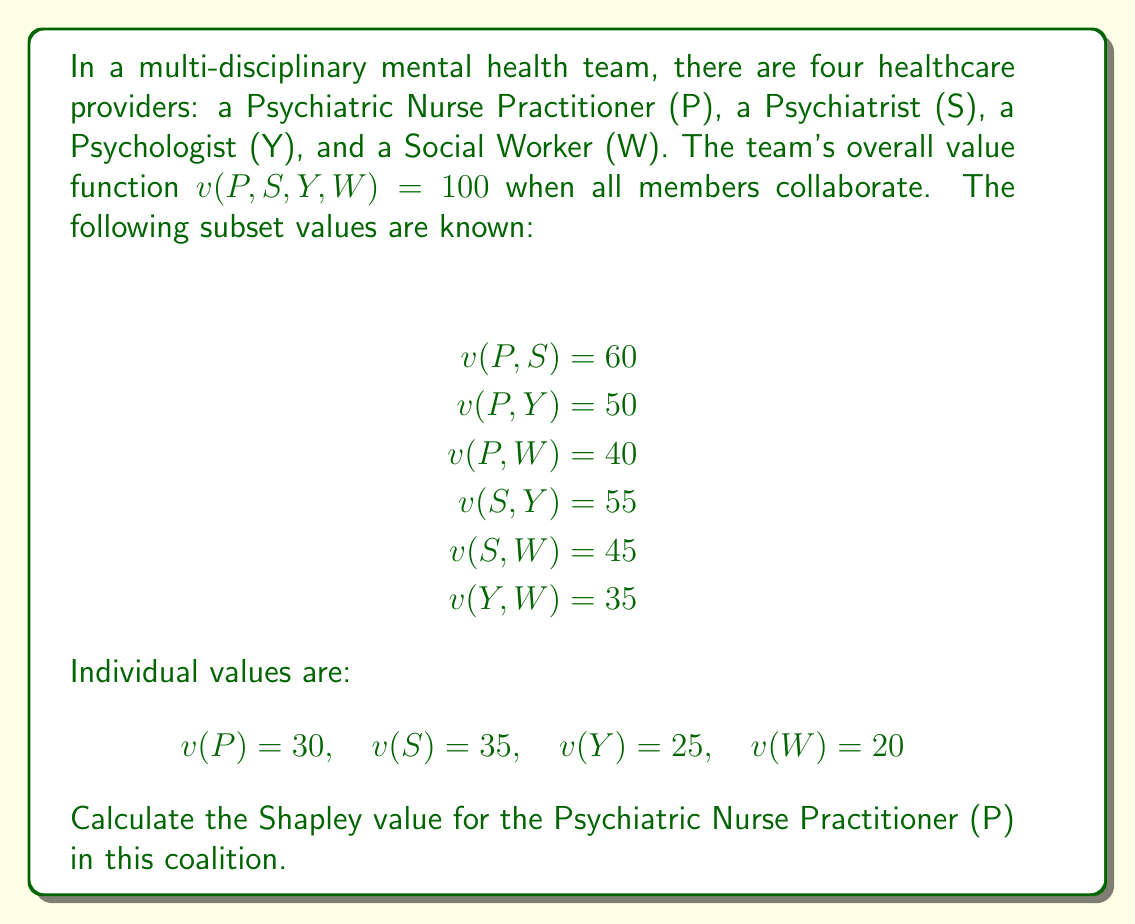Give your solution to this math problem. To calculate the Shapley value for the Psychiatric Nurse Practitioner (P), we need to determine their marginal contribution to each possible coalition and then take the average of these contributions.

The Shapley value formula for player $i$ is:

$$ \phi_i(v) = \sum_{S \subseteq N \setminus \{i\}} \frac{|S|!(n-|S|-1)!}{n!}[v(S \cup \{i\}) - v(S)] $$

Where $N$ is the set of all players, $n$ is the total number of players, and $S$ is a subset of players not including $i$.

For the Psychiatric Nurse Practitioner (P), we need to calculate:

1) P joins an empty coalition: $v(P) - v(\emptyset) = 30 - 0 = 30$
2) P joins W: $v(P,W) - v(W) = 40 - 20 = 20$
3) P joins Y: $v(P,Y) - v(Y) = 50 - 25 = 25$
4) P joins S: $v(P,S) - v(S) = 60 - 35 = 25$
5) P joins (Y,W): $v(P,Y,W) - v(Y,W) = 100 - 35 = 65$
6) P joins (S,W): $v(P,S,W) - v(S,W) = 100 - 45 = 55$
7) P joins (S,Y): $v(P,S,Y) - v(S,Y) = 100 - 55 = 45$
8) P joins (S,Y,W): $v(P,S,Y,W) - v(S,Y,W) = 100 - 100 = 0$

Now, we calculate the weighted average:

$$ \phi_P = \frac{1}{4!}[3!(30) + 2!(20+25+25) + 1!(65+55+45) + 0!(0)] $$
$$ \phi_P = \frac{1}{24}[6(30) + 2(70) + 165 + 0] $$
$$ \phi_P = \frac{1}{24}[180 + 140 + 165] $$
$$ \phi_P = \frac{485}{24} $$
$$ \phi_P = 20.2083333... $$
Answer: The Shapley value for the Psychiatric Nurse Practitioner (P) is $\frac{485}{24} \approx 20.21$. 